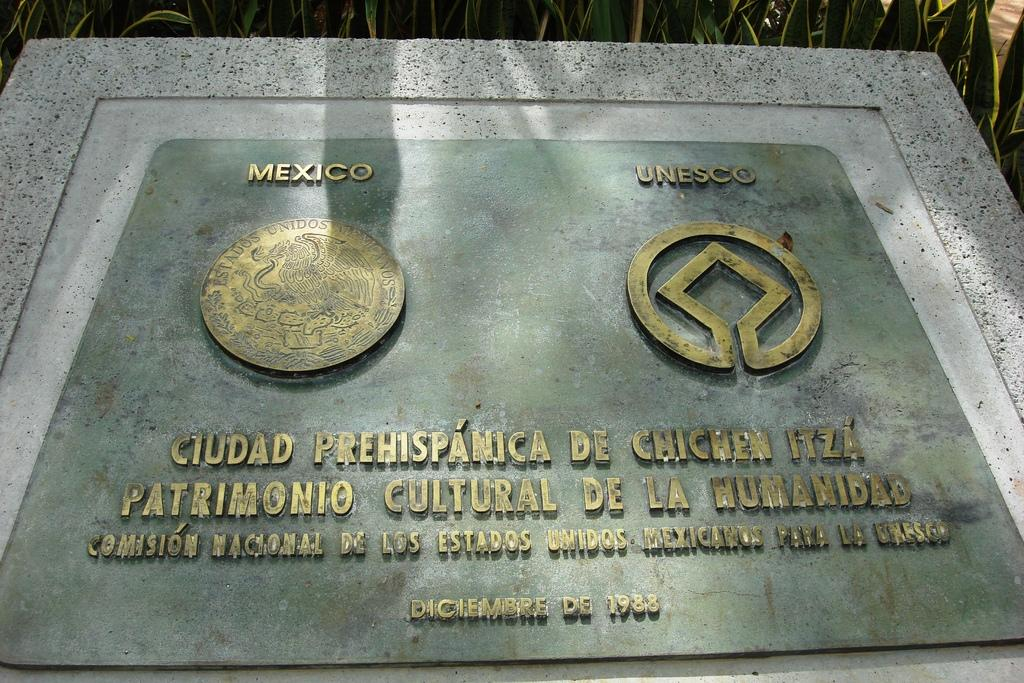<image>
Give a short and clear explanation of the subsequent image. the word ciudad is on the plaque that is gray 